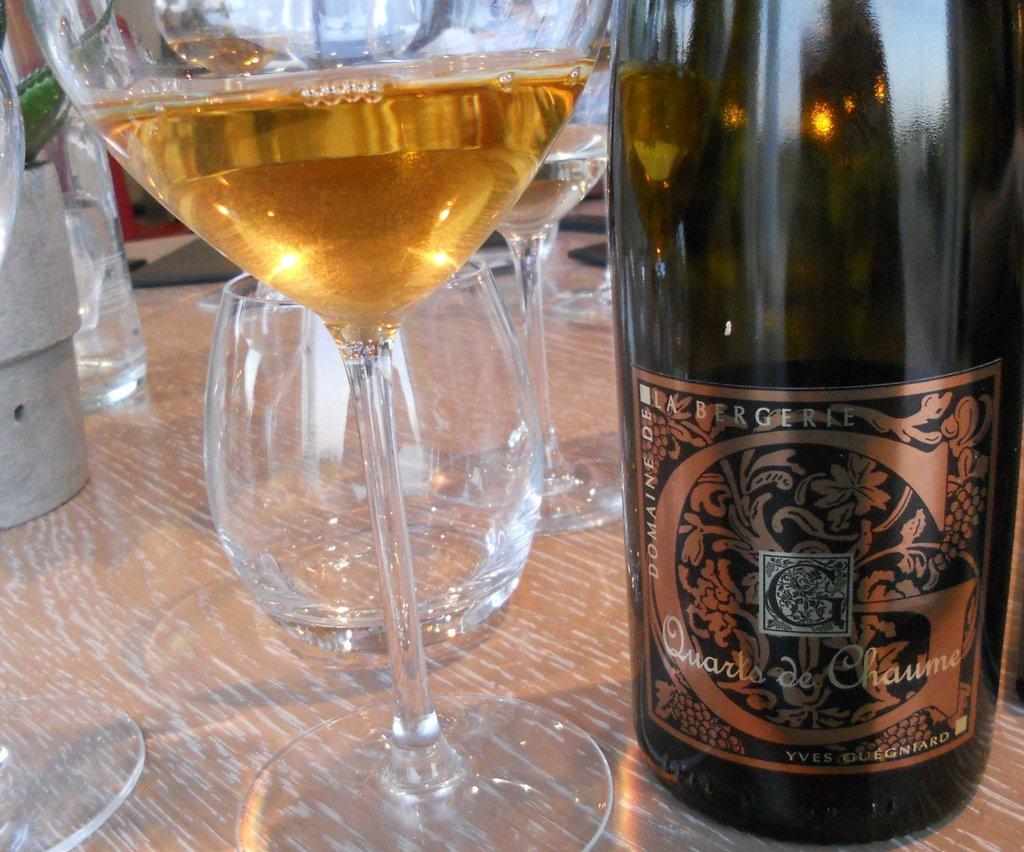<image>
Provide a brief description of the given image. A glass and a bottle of Quartz de Chaume. 